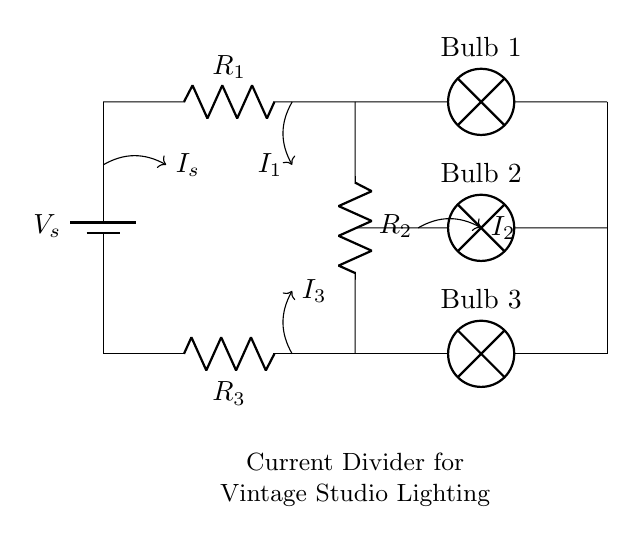What is the total number of resistors in the circuit? There are three resistors labeled as R1, R2, and R3 in the circuit.
Answer: three What is the purpose of the current divider in this circuit? The current divider is used to control the brightness of the incandescent bulbs by splitting the total current into individual branches, allowing different amounts of current to flow through each bulb.
Answer: control brightness Which bulb receives the highest current? Bulb 1 is positioned in the branch with the greatest resistance (R1), hence it would receive the most current compared to the others.
Answer: Bulb 1 What happens to the current if the resistance of R2 is decreased? Decreasing R2 would increase the current flowing through that branch (Bulb 2), making it brighter compared to the others, as the total current remains constant.
Answer: increases What is the relationship between the resistance values and the current through each bulb? The current through each bulb is inversely proportional to the resistance in its branch; lower resistance results in higher current, thus affecting brightness.
Answer: inverse relationship How many bulbs are connected to the circuit? There are three bulbs labeled as Bulb 1, Bulb 2, and Bulb 3 connected in parallel to the resistors.
Answer: three What is the source of voltage in this circuit? The voltage source is labeled as Vs and is indicated at the top of the circuit diagram, providing the necessary potential difference for the circuit.
Answer: Vs 